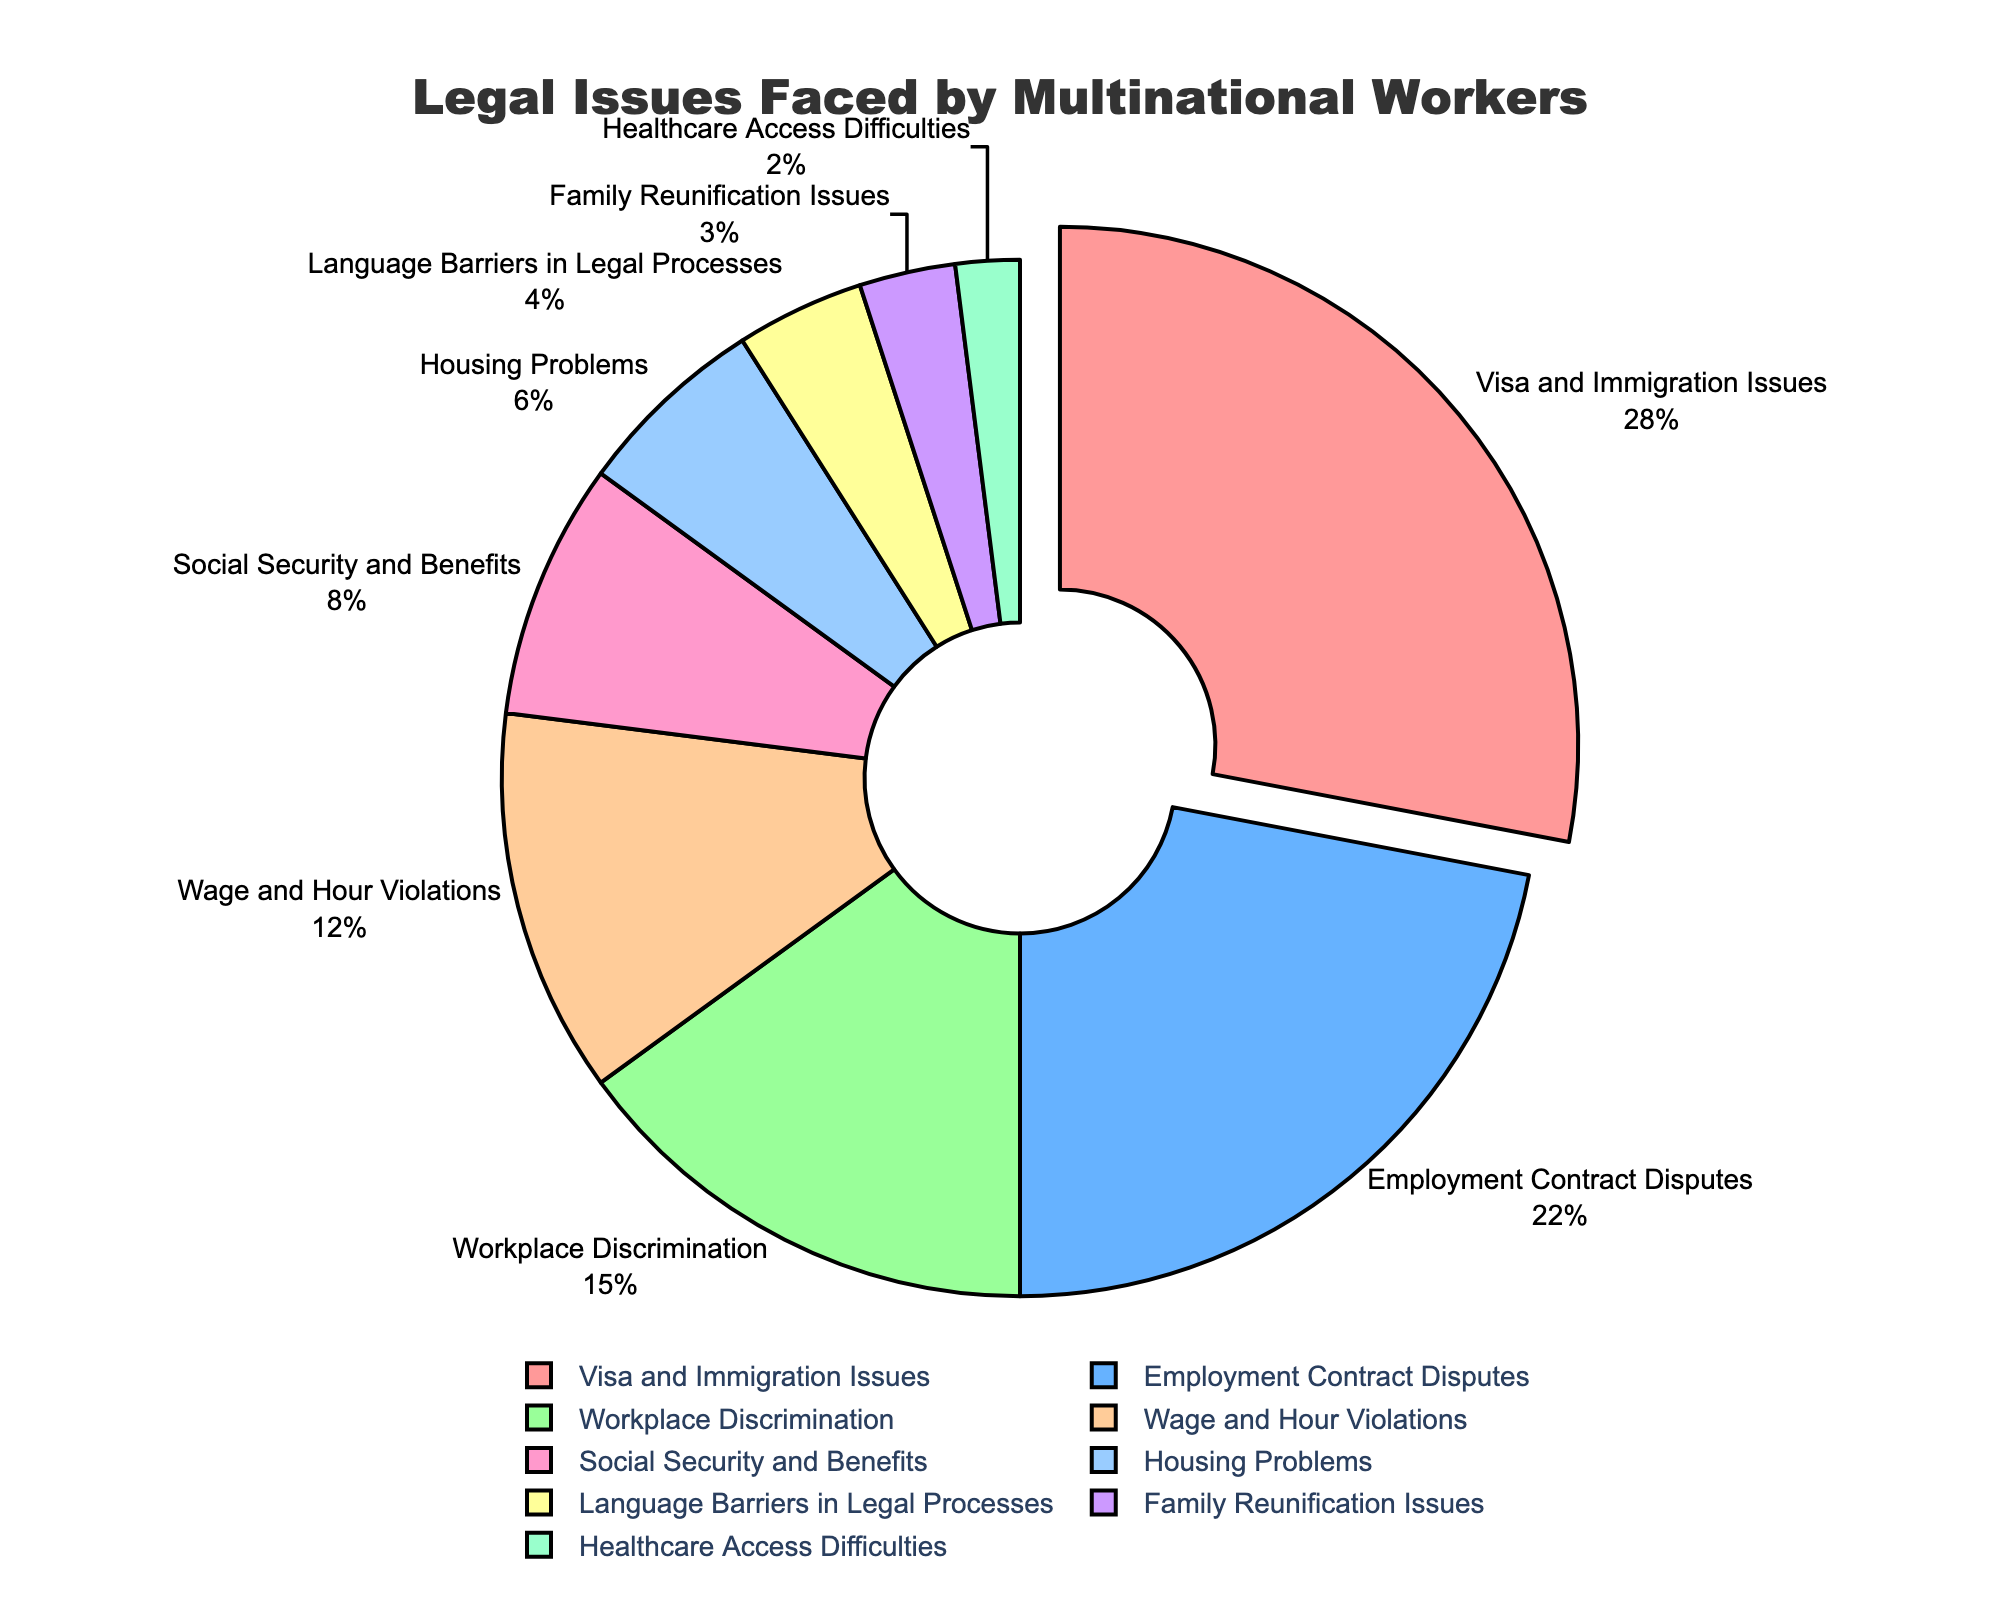What type of legal issue is faced by the highest percentage of multinational workers? The largest segment of the pie chart is pulled out and labeled “Visa and Immigration Issues” with 28%.
Answer: Visa and Immigration Issues Which two categories combined form the largest percentage of legal issues faced by multinational workers? The two largest segments are labeled “Visa and Immigration Issues” (28%) and “Employment Contract Disputes” (22%). Combined, these form 50%.
Answer: Visa and Immigration Issues and Employment Contract Disputes What percentage of legal issues are related to wage, hour violations, and language barriers in legal processes together? Add the percentages of “Wage and Hour Violations” (12%) and “Language Barriers in Legal Processes” (4%). This sums up to 16%.
Answer: 16% Is the percentage of workers facing social security and benefits issues higher, lower, or equal to those facing housing problems? The percentage for “Social Security and Benefits” is 8%, which is higher than “Housing Problems” at 6%.
Answer: Higher What is the combined percentage of the least frequent three types of legal issues faced by multinational workers? Add the percentages of “Family Reunification Issues” (3%), “Healthcare Access Difficulties” (2%), and “Language Barriers in Legal Processes” (4%). This sums up to 9%.
Answer: 9% How does the percentage of workers facing employment contract disputes compare to the percentage facing workplace discrimination? The percentage for “Employment Contract Disputes” is 22%, which is higher than “Workplace Discrimination” at 15%.
Answer: Higher What is the total percentage of the top three types of legal issues faced by multinational workers? Add the percentages of “Visa and Immigration Issues” (28%), “Employment Contract Disputes” (22%), and “Workplace Discrimination” (15%). This sums up to 65%.
Answer: 65% Which category is represented by the smallest segment in the pie chart? The smallest segment is labeled “Healthcare Access Difficulties” with 2%.
Answer: Healthcare Access Difficulties What percentage of issues faced by multinational workers are related to housing or healthcare access? Add the percentages of “Housing Problems” (6%) and “Healthcare Access Difficulties” (2%). This sums up to 8%.
Answer: 8% Is the percentage of workers facing wage and hour violations greater than the percentage facing social security and benefits but less than workplace discrimination? The percentage for “Wage and Hour Violations” (12%) is greater than “Social Security and Benefits” (8%) and less than “Workplace Discrimination” (15%).
Answer: Yes 